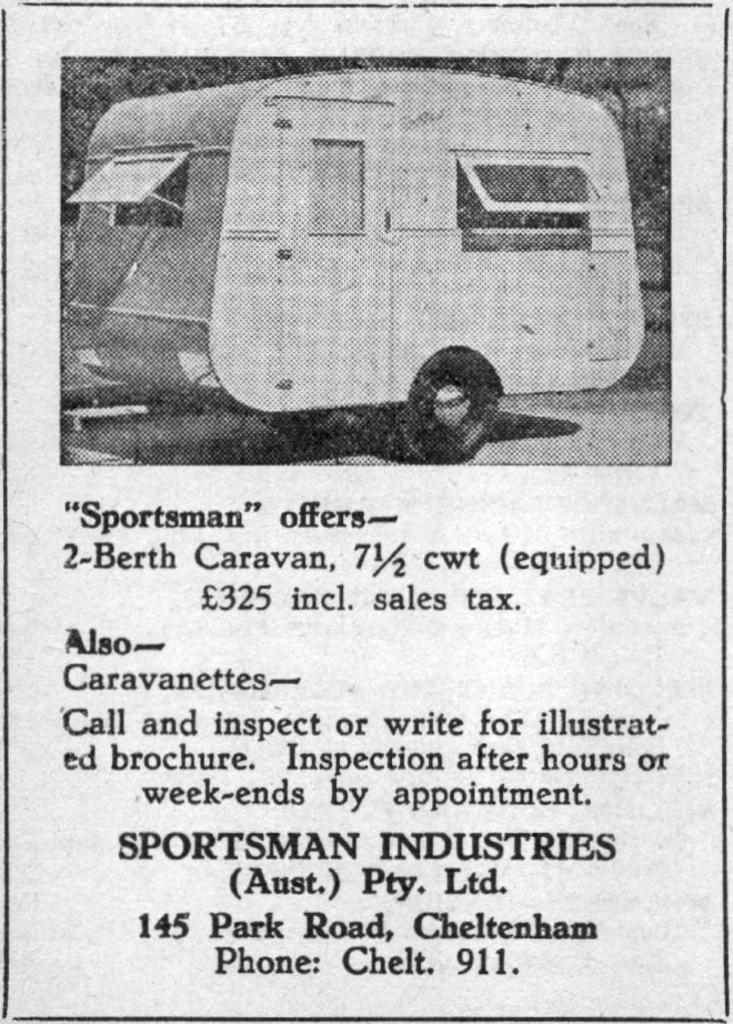What is the color scheme of the image? The image is black and white. What can be seen at the top of the image? There is a vehicle at the top of the image. What is located at the bottom of the image? There is text at the bottom of the image. Can you see any yarn being used by the ant in the image? There is no yarn or ant present in the image. Who is the friend of the vehicle in the image? The image does not depict any friends or relationships between the subjects; it only shows a vehicle and text. 